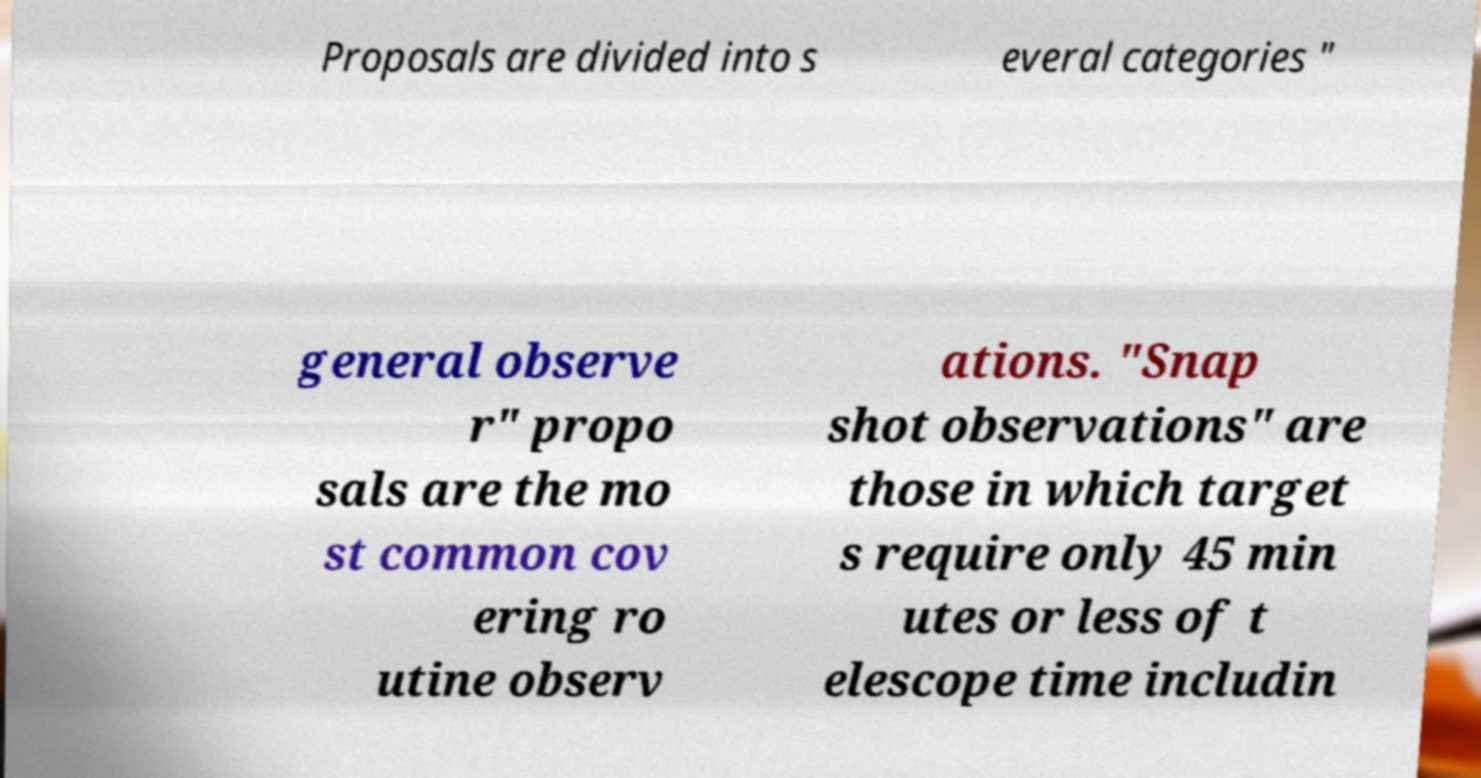I need the written content from this picture converted into text. Can you do that? Proposals are divided into s everal categories " general observe r" propo sals are the mo st common cov ering ro utine observ ations. "Snap shot observations" are those in which target s require only 45 min utes or less of t elescope time includin 